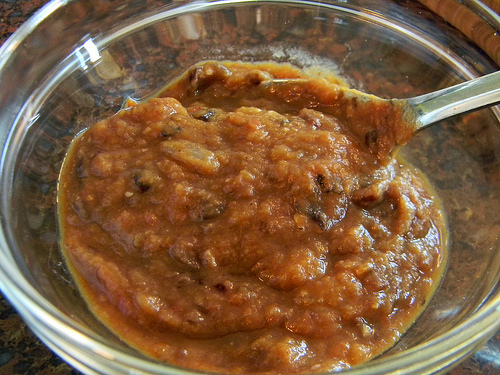<image>
Is there a spoon behind the plate? No. The spoon is not behind the plate. From this viewpoint, the spoon appears to be positioned elsewhere in the scene. 